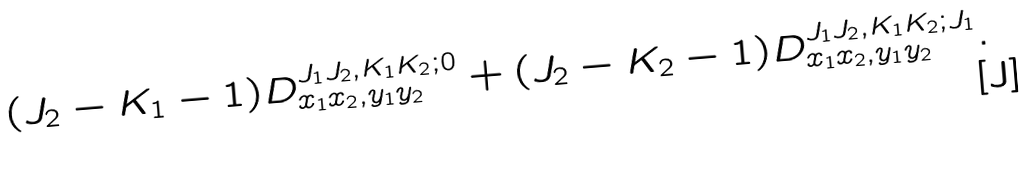Convert formula to latex. <formula><loc_0><loc_0><loc_500><loc_500>( J _ { 2 } - K _ { 1 } - 1 ) D ^ { J _ { 1 } J _ { 2 } , K _ { 1 } K _ { 2 } ; 0 } _ { x _ { 1 } x _ { 2 } , y _ { 1 } y _ { 2 } } + ( J _ { 2 } - K _ { 2 } - 1 ) D ^ { J _ { 1 } J _ { 2 } , K _ { 1 } K _ { 2 } ; J _ { 1 } } _ { x _ { 1 } x _ { 2 } , y _ { 1 } y _ { 2 } } .</formula> 